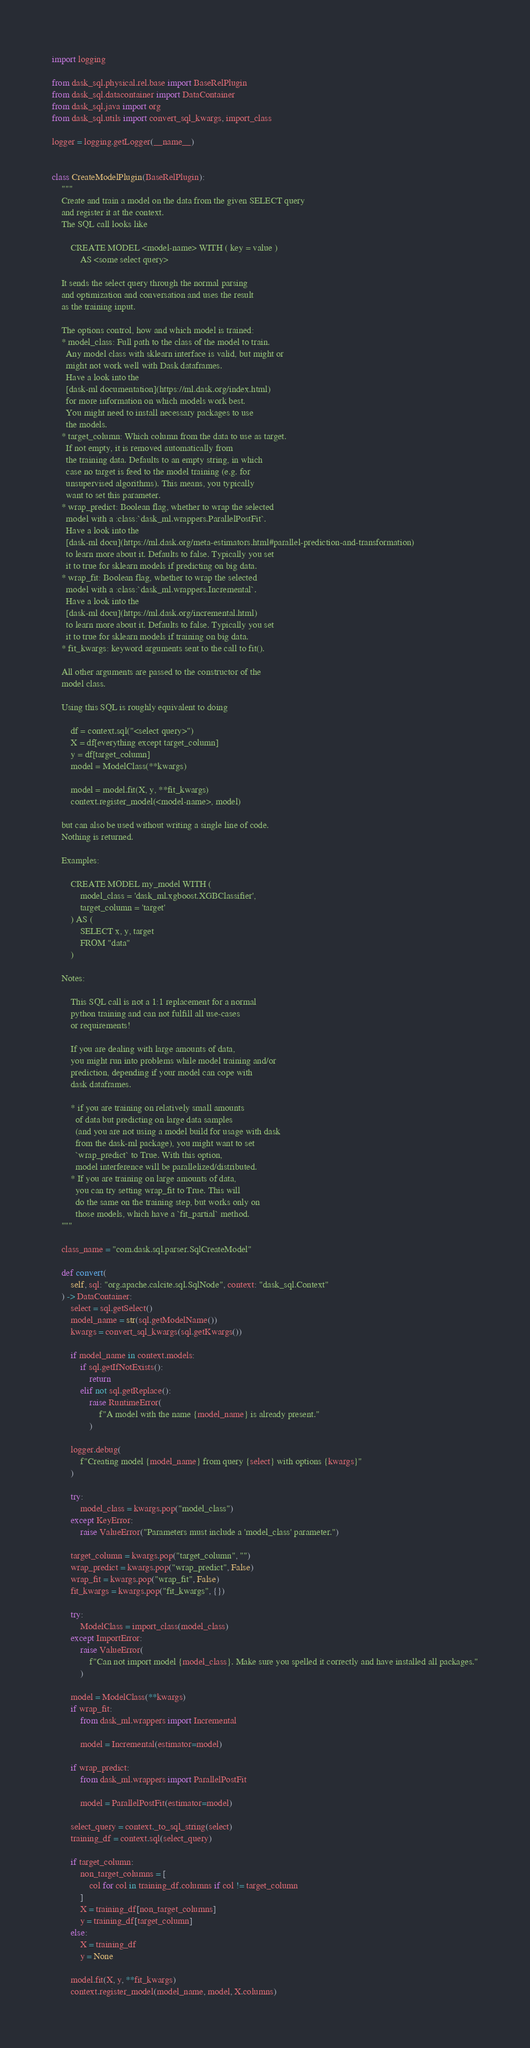<code> <loc_0><loc_0><loc_500><loc_500><_Python_>import logging

from dask_sql.physical.rel.base import BaseRelPlugin
from dask_sql.datacontainer import DataContainer
from dask_sql.java import org
from dask_sql.utils import convert_sql_kwargs, import_class

logger = logging.getLogger(__name__)


class CreateModelPlugin(BaseRelPlugin):
    """
    Create and train a model on the data from the given SELECT query
    and register it at the context.
    The SQL call looks like

        CREATE MODEL <model-name> WITH ( key = value )
            AS <some select query>

    It sends the select query through the normal parsing
    and optimization and conversation and uses the result
    as the training input.

    The options control, how and which model is trained:
    * model_class: Full path to the class of the model to train.
      Any model class with sklearn interface is valid, but might or
      might not work well with Dask dataframes.
      Have a look into the
      [dask-ml documentation](https://ml.dask.org/index.html)
      for more information on which models work best.
      You might need to install necessary packages to use
      the models.
    * target_column: Which column from the data to use as target.
      If not empty, it is removed automatically from
      the training data. Defaults to an empty string, in which
      case no target is feed to the model training (e.g. for
      unsupervised algorithms). This means, you typically
      want to set this parameter.
    * wrap_predict: Boolean flag, whether to wrap the selected
      model with a :class:`dask_ml.wrappers.ParallelPostFit`.
      Have a look into the
      [dask-ml docu](https://ml.dask.org/meta-estimators.html#parallel-prediction-and-transformation)
      to learn more about it. Defaults to false. Typically you set
      it to true for sklearn models if predicting on big data.
    * wrap_fit: Boolean flag, whether to wrap the selected
      model with a :class:`dask_ml.wrappers.Incremental`.
      Have a look into the
      [dask-ml docu](https://ml.dask.org/incremental.html)
      to learn more about it. Defaults to false. Typically you set
      it to true for sklearn models if training on big data.
    * fit_kwargs: keyword arguments sent to the call to fit().

    All other arguments are passed to the constructor of the
    model class.

    Using this SQL is roughly equivalent to doing

        df = context.sql("<select query>")
        X = df[everything except target_column]
        y = df[target_column]
        model = ModelClass(**kwargs)

        model = model.fit(X, y, **fit_kwargs)
        context.register_model(<model-name>, model)

    but can also be used without writing a single line of code.
    Nothing is returned.

    Examples:

        CREATE MODEL my_model WITH (
            model_class = 'dask_ml.xgboost.XGBClassifier',
            target_column = 'target'
        ) AS (
            SELECT x, y, target
            FROM "data"
        )

    Notes:

        This SQL call is not a 1:1 replacement for a normal
        python training and can not fulfill all use-cases
        or requirements!

        If you are dealing with large amounts of data,
        you might run into problems while model training and/or
        prediction, depending if your model can cope with
        dask dataframes.

        * if you are training on relatively small amounts
          of data but predicting on large data samples
          (and you are not using a model build for usage with dask
          from the dask-ml package), you might want to set
          `wrap_predict` to True. With this option,
          model interference will be parallelized/distributed.
        * If you are training on large amounts of data,
          you can try setting wrap_fit to True. This will
          do the same on the training step, but works only on
          those models, which have a `fit_partial` method.
    """

    class_name = "com.dask.sql.parser.SqlCreateModel"

    def convert(
        self, sql: "org.apache.calcite.sql.SqlNode", context: "dask_sql.Context"
    ) -> DataContainer:
        select = sql.getSelect()
        model_name = str(sql.getModelName())
        kwargs = convert_sql_kwargs(sql.getKwargs())

        if model_name in context.models:
            if sql.getIfNotExists():
                return
            elif not sql.getReplace():
                raise RuntimeError(
                    f"A model with the name {model_name} is already present."
                )

        logger.debug(
            f"Creating model {model_name} from query {select} with options {kwargs}"
        )

        try:
            model_class = kwargs.pop("model_class")
        except KeyError:
            raise ValueError("Parameters must include a 'model_class' parameter.")

        target_column = kwargs.pop("target_column", "")
        wrap_predict = kwargs.pop("wrap_predict", False)
        wrap_fit = kwargs.pop("wrap_fit", False)
        fit_kwargs = kwargs.pop("fit_kwargs", {})

        try:
            ModelClass = import_class(model_class)
        except ImportError:
            raise ValueError(
                f"Can not import model {model_class}. Make sure you spelled it correctly and have installed all packages."
            )

        model = ModelClass(**kwargs)
        if wrap_fit:
            from dask_ml.wrappers import Incremental

            model = Incremental(estimator=model)

        if wrap_predict:
            from dask_ml.wrappers import ParallelPostFit

            model = ParallelPostFit(estimator=model)

        select_query = context._to_sql_string(select)
        training_df = context.sql(select_query)

        if target_column:
            non_target_columns = [
                col for col in training_df.columns if col != target_column
            ]
            X = training_df[non_target_columns]
            y = training_df[target_column]
        else:
            X = training_df
            y = None

        model.fit(X, y, **fit_kwargs)
        context.register_model(model_name, model, X.columns)
</code> 